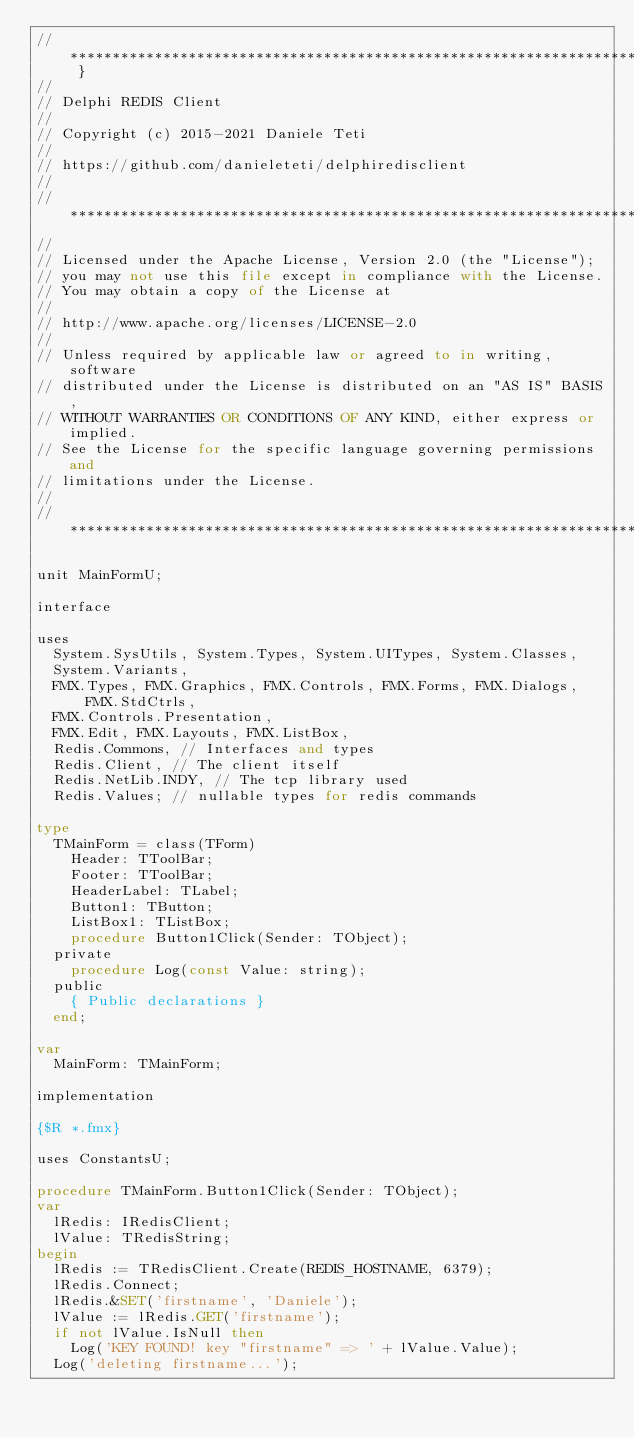Convert code to text. <code><loc_0><loc_0><loc_500><loc_500><_Pascal_>// *************************************************************************** }
//
// Delphi REDIS Client
//
// Copyright (c) 2015-2021 Daniele Teti
//
// https://github.com/danieleteti/delphiredisclient
//
// ***************************************************************************
//
// Licensed under the Apache License, Version 2.0 (the "License");
// you may not use this file except in compliance with the License.
// You may obtain a copy of the License at
//
// http://www.apache.org/licenses/LICENSE-2.0
//
// Unless required by applicable law or agreed to in writing, software
// distributed under the License is distributed on an "AS IS" BASIS,
// WITHOUT WARRANTIES OR CONDITIONS OF ANY KIND, either express or implied.
// See the License for the specific language governing permissions and
// limitations under the License.
//
// ***************************************************************************

unit MainFormU;

interface

uses
  System.SysUtils, System.Types, System.UITypes, System.Classes,
  System.Variants,
  FMX.Types, FMX.Graphics, FMX.Controls, FMX.Forms, FMX.Dialogs, FMX.StdCtrls,
  FMX.Controls.Presentation,
  FMX.Edit, FMX.Layouts, FMX.ListBox,
  Redis.Commons, // Interfaces and types
  Redis.Client, // The client itself
  Redis.NetLib.INDY, // The tcp library used
  Redis.Values; // nullable types for redis commands

type
  TMainForm = class(TForm)
    Header: TToolBar;
    Footer: TToolBar;
    HeaderLabel: TLabel;
    Button1: TButton;
    ListBox1: TListBox;
    procedure Button1Click(Sender: TObject);
  private
    procedure Log(const Value: string);
  public
    { Public declarations }
  end;

var
  MainForm: TMainForm;

implementation

{$R *.fmx}

uses ConstantsU;

procedure TMainForm.Button1Click(Sender: TObject);
var
  lRedis: IRedisClient;
  lValue: TRedisString;
begin
  lRedis := TRedisClient.Create(REDIS_HOSTNAME, 6379);
  lRedis.Connect;
  lRedis.&SET('firstname', 'Daniele');
  lValue := lRedis.GET('firstname');
  if not lValue.IsNull then
    Log('KEY FOUND! key "firstname" => ' + lValue.Value);
  Log('deleting firstname...');</code> 